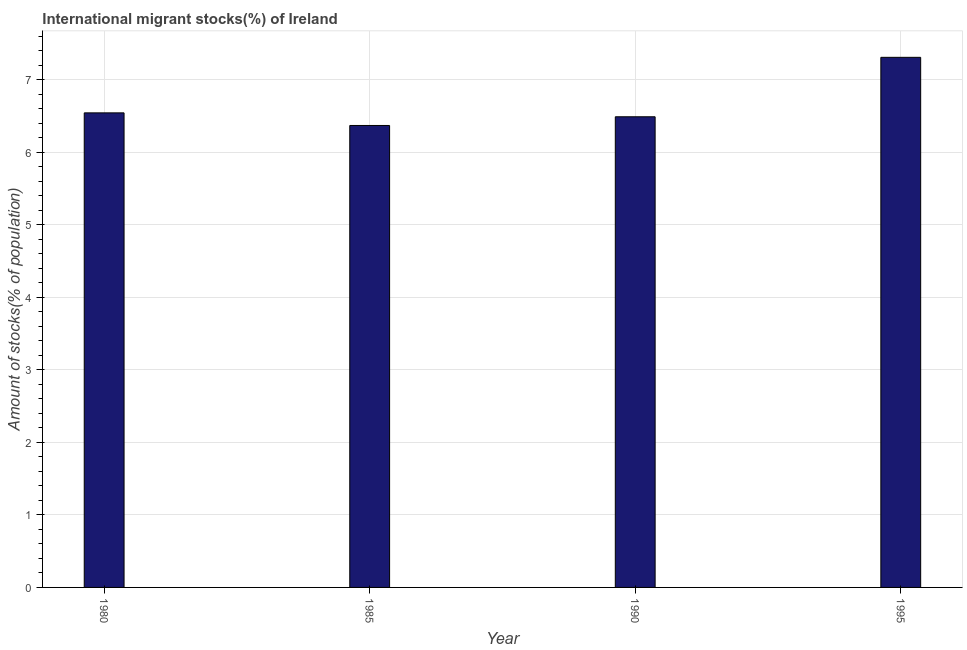Does the graph contain any zero values?
Ensure brevity in your answer.  No. Does the graph contain grids?
Your response must be concise. Yes. What is the title of the graph?
Give a very brief answer. International migrant stocks(%) of Ireland. What is the label or title of the X-axis?
Your response must be concise. Year. What is the label or title of the Y-axis?
Your answer should be compact. Amount of stocks(% of population). What is the number of international migrant stocks in 1995?
Your answer should be very brief. 7.31. Across all years, what is the maximum number of international migrant stocks?
Make the answer very short. 7.31. Across all years, what is the minimum number of international migrant stocks?
Keep it short and to the point. 6.37. What is the sum of the number of international migrant stocks?
Keep it short and to the point. 26.7. What is the difference between the number of international migrant stocks in 1985 and 1990?
Offer a very short reply. -0.12. What is the average number of international migrant stocks per year?
Your response must be concise. 6.68. What is the median number of international migrant stocks?
Provide a succinct answer. 6.51. In how many years, is the number of international migrant stocks greater than 2.6 %?
Your answer should be very brief. 4. Do a majority of the years between 1985 and 1980 (inclusive) have number of international migrant stocks greater than 2 %?
Offer a terse response. No. What is the ratio of the number of international migrant stocks in 1990 to that in 1995?
Keep it short and to the point. 0.89. What is the difference between the highest and the second highest number of international migrant stocks?
Ensure brevity in your answer.  0.77. Is the sum of the number of international migrant stocks in 1980 and 1990 greater than the maximum number of international migrant stocks across all years?
Make the answer very short. Yes. What is the difference between the highest and the lowest number of international migrant stocks?
Make the answer very short. 0.94. In how many years, is the number of international migrant stocks greater than the average number of international migrant stocks taken over all years?
Provide a short and direct response. 1. What is the difference between two consecutive major ticks on the Y-axis?
Make the answer very short. 1. Are the values on the major ticks of Y-axis written in scientific E-notation?
Your answer should be very brief. No. What is the Amount of stocks(% of population) in 1980?
Offer a terse response. 6.54. What is the Amount of stocks(% of population) of 1985?
Ensure brevity in your answer.  6.37. What is the Amount of stocks(% of population) of 1990?
Keep it short and to the point. 6.49. What is the Amount of stocks(% of population) of 1995?
Make the answer very short. 7.31. What is the difference between the Amount of stocks(% of population) in 1980 and 1985?
Give a very brief answer. 0.17. What is the difference between the Amount of stocks(% of population) in 1980 and 1990?
Provide a succinct answer. 0.05. What is the difference between the Amount of stocks(% of population) in 1980 and 1995?
Keep it short and to the point. -0.77. What is the difference between the Amount of stocks(% of population) in 1985 and 1990?
Your answer should be very brief. -0.12. What is the difference between the Amount of stocks(% of population) in 1985 and 1995?
Offer a very short reply. -0.94. What is the difference between the Amount of stocks(% of population) in 1990 and 1995?
Provide a succinct answer. -0.82. What is the ratio of the Amount of stocks(% of population) in 1980 to that in 1985?
Ensure brevity in your answer.  1.03. What is the ratio of the Amount of stocks(% of population) in 1980 to that in 1990?
Your answer should be very brief. 1.01. What is the ratio of the Amount of stocks(% of population) in 1980 to that in 1995?
Provide a short and direct response. 0.9. What is the ratio of the Amount of stocks(% of population) in 1985 to that in 1995?
Your response must be concise. 0.87. What is the ratio of the Amount of stocks(% of population) in 1990 to that in 1995?
Your response must be concise. 0.89. 